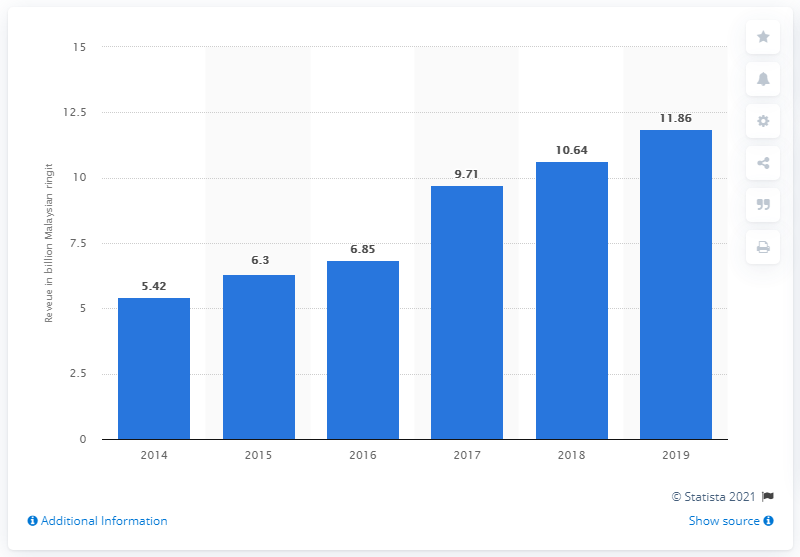Highlight a few significant elements in this photo. AirAsia generated 11.86 Malaysian ringgit in 2019. 